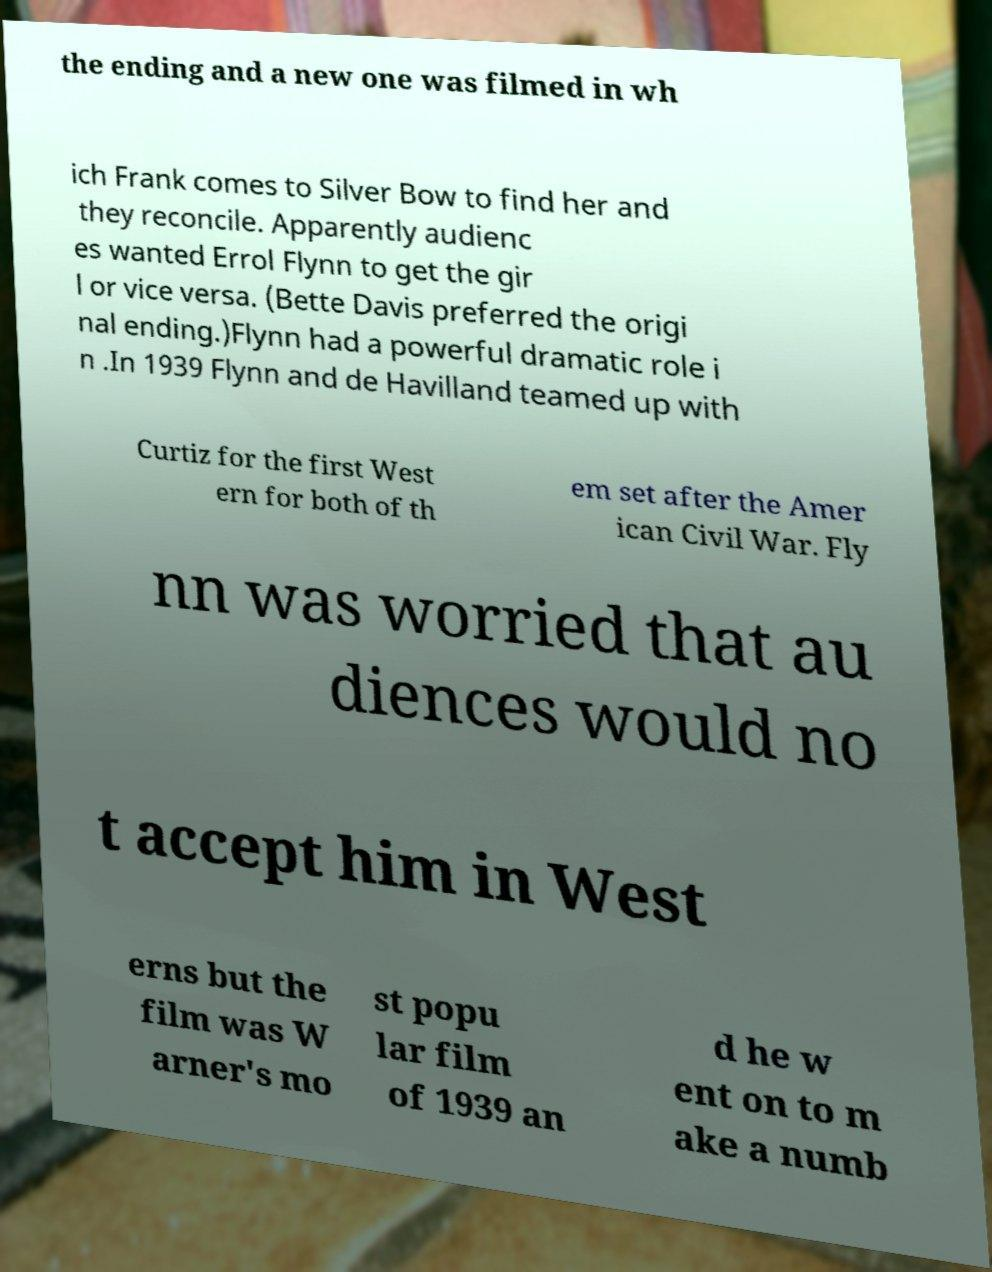There's text embedded in this image that I need extracted. Can you transcribe it verbatim? the ending and a new one was filmed in wh ich Frank comes to Silver Bow to find her and they reconcile. Apparently audienc es wanted Errol Flynn to get the gir l or vice versa. (Bette Davis preferred the origi nal ending.)Flynn had a powerful dramatic role i n .In 1939 Flynn and de Havilland teamed up with Curtiz for the first West ern for both of th em set after the Amer ican Civil War. Fly nn was worried that au diences would no t accept him in West erns but the film was W arner's mo st popu lar film of 1939 an d he w ent on to m ake a numb 